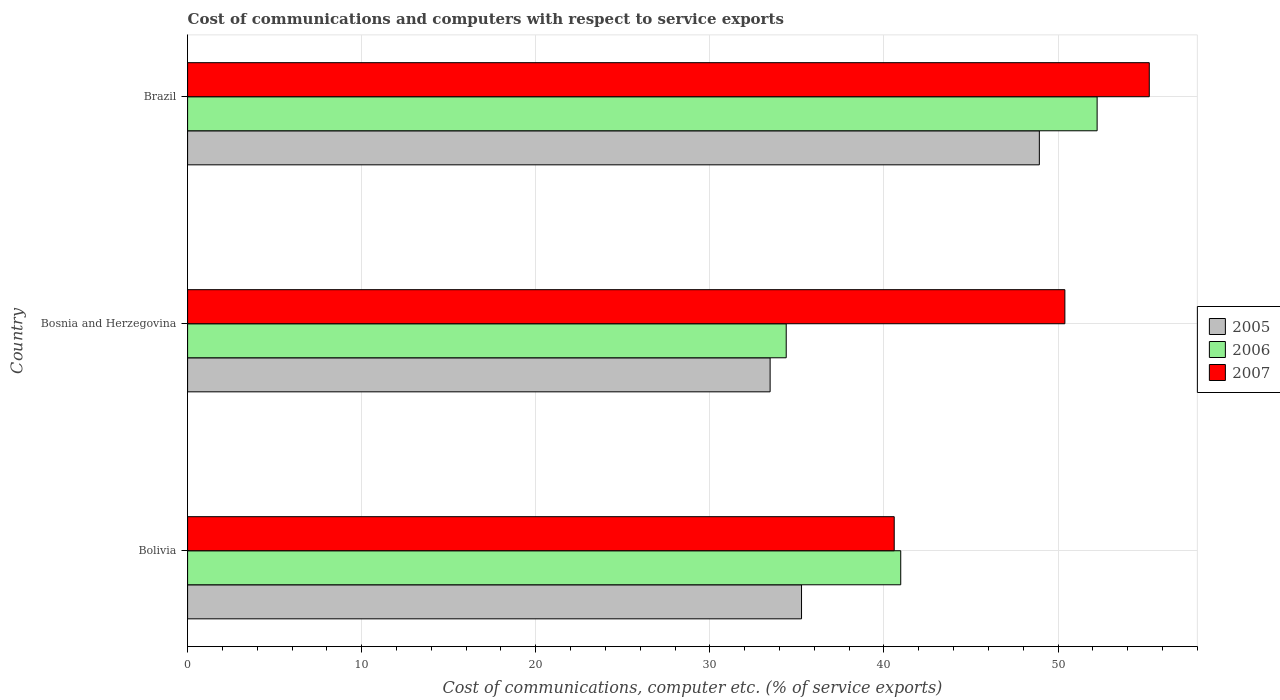How many different coloured bars are there?
Offer a very short reply. 3. How many groups of bars are there?
Your answer should be compact. 3. Are the number of bars per tick equal to the number of legend labels?
Offer a very short reply. Yes. How many bars are there on the 2nd tick from the bottom?
Give a very brief answer. 3. What is the label of the 2nd group of bars from the top?
Make the answer very short. Bosnia and Herzegovina. In how many cases, is the number of bars for a given country not equal to the number of legend labels?
Offer a very short reply. 0. What is the cost of communications and computers in 2006 in Bosnia and Herzegovina?
Your answer should be compact. 34.38. Across all countries, what is the maximum cost of communications and computers in 2005?
Your response must be concise. 48.92. Across all countries, what is the minimum cost of communications and computers in 2006?
Your answer should be very brief. 34.38. In which country was the cost of communications and computers in 2007 maximum?
Your answer should be very brief. Brazil. In which country was the cost of communications and computers in 2005 minimum?
Provide a short and direct response. Bosnia and Herzegovina. What is the total cost of communications and computers in 2007 in the graph?
Provide a succinct answer. 146.22. What is the difference between the cost of communications and computers in 2005 in Bosnia and Herzegovina and that in Brazil?
Make the answer very short. -15.46. What is the difference between the cost of communications and computers in 2005 in Bolivia and the cost of communications and computers in 2007 in Bosnia and Herzegovina?
Provide a short and direct response. -15.13. What is the average cost of communications and computers in 2006 per country?
Offer a very short reply. 42.53. What is the difference between the cost of communications and computers in 2006 and cost of communications and computers in 2005 in Brazil?
Offer a very short reply. 3.32. What is the ratio of the cost of communications and computers in 2005 in Bolivia to that in Bosnia and Herzegovina?
Provide a short and direct response. 1.05. Is the cost of communications and computers in 2007 in Bolivia less than that in Bosnia and Herzegovina?
Provide a succinct answer. Yes. Is the difference between the cost of communications and computers in 2006 in Bolivia and Bosnia and Herzegovina greater than the difference between the cost of communications and computers in 2005 in Bolivia and Bosnia and Herzegovina?
Offer a very short reply. Yes. What is the difference between the highest and the second highest cost of communications and computers in 2005?
Keep it short and to the point. 13.66. What is the difference between the highest and the lowest cost of communications and computers in 2006?
Your response must be concise. 17.86. What does the 2nd bar from the top in Bosnia and Herzegovina represents?
Keep it short and to the point. 2006. How many bars are there?
Offer a very short reply. 9. Are the values on the major ticks of X-axis written in scientific E-notation?
Your answer should be compact. No. Does the graph contain any zero values?
Give a very brief answer. No. Does the graph contain grids?
Give a very brief answer. Yes. Where does the legend appear in the graph?
Offer a terse response. Center right. How many legend labels are there?
Your response must be concise. 3. How are the legend labels stacked?
Make the answer very short. Vertical. What is the title of the graph?
Ensure brevity in your answer.  Cost of communications and computers with respect to service exports. Does "2013" appear as one of the legend labels in the graph?
Your response must be concise. No. What is the label or title of the X-axis?
Offer a terse response. Cost of communications, computer etc. (% of service exports). What is the label or title of the Y-axis?
Ensure brevity in your answer.  Country. What is the Cost of communications, computer etc. (% of service exports) in 2005 in Bolivia?
Your response must be concise. 35.26. What is the Cost of communications, computer etc. (% of service exports) in 2006 in Bolivia?
Offer a terse response. 40.96. What is the Cost of communications, computer etc. (% of service exports) of 2007 in Bolivia?
Make the answer very short. 40.59. What is the Cost of communications, computer etc. (% of service exports) in 2005 in Bosnia and Herzegovina?
Provide a succinct answer. 33.46. What is the Cost of communications, computer etc. (% of service exports) in 2006 in Bosnia and Herzegovina?
Give a very brief answer. 34.38. What is the Cost of communications, computer etc. (% of service exports) in 2007 in Bosnia and Herzegovina?
Offer a very short reply. 50.39. What is the Cost of communications, computer etc. (% of service exports) in 2005 in Brazil?
Make the answer very short. 48.92. What is the Cost of communications, computer etc. (% of service exports) of 2006 in Brazil?
Your answer should be compact. 52.24. What is the Cost of communications, computer etc. (% of service exports) in 2007 in Brazil?
Give a very brief answer. 55.24. Across all countries, what is the maximum Cost of communications, computer etc. (% of service exports) in 2005?
Provide a succinct answer. 48.92. Across all countries, what is the maximum Cost of communications, computer etc. (% of service exports) of 2006?
Your response must be concise. 52.24. Across all countries, what is the maximum Cost of communications, computer etc. (% of service exports) of 2007?
Your answer should be compact. 55.24. Across all countries, what is the minimum Cost of communications, computer etc. (% of service exports) in 2005?
Give a very brief answer. 33.46. Across all countries, what is the minimum Cost of communications, computer etc. (% of service exports) in 2006?
Ensure brevity in your answer.  34.38. Across all countries, what is the minimum Cost of communications, computer etc. (% of service exports) of 2007?
Your answer should be compact. 40.59. What is the total Cost of communications, computer etc. (% of service exports) in 2005 in the graph?
Keep it short and to the point. 117.65. What is the total Cost of communications, computer etc. (% of service exports) of 2006 in the graph?
Ensure brevity in your answer.  127.59. What is the total Cost of communications, computer etc. (% of service exports) of 2007 in the graph?
Provide a short and direct response. 146.22. What is the difference between the Cost of communications, computer etc. (% of service exports) in 2005 in Bolivia and that in Bosnia and Herzegovina?
Keep it short and to the point. 1.8. What is the difference between the Cost of communications, computer etc. (% of service exports) in 2006 in Bolivia and that in Bosnia and Herzegovina?
Your response must be concise. 6.58. What is the difference between the Cost of communications, computer etc. (% of service exports) in 2007 in Bolivia and that in Bosnia and Herzegovina?
Give a very brief answer. -9.8. What is the difference between the Cost of communications, computer etc. (% of service exports) in 2005 in Bolivia and that in Brazil?
Ensure brevity in your answer.  -13.66. What is the difference between the Cost of communications, computer etc. (% of service exports) of 2006 in Bolivia and that in Brazil?
Provide a short and direct response. -11.28. What is the difference between the Cost of communications, computer etc. (% of service exports) of 2007 in Bolivia and that in Brazil?
Provide a short and direct response. -14.65. What is the difference between the Cost of communications, computer etc. (% of service exports) of 2005 in Bosnia and Herzegovina and that in Brazil?
Offer a very short reply. -15.46. What is the difference between the Cost of communications, computer etc. (% of service exports) of 2006 in Bosnia and Herzegovina and that in Brazil?
Keep it short and to the point. -17.86. What is the difference between the Cost of communications, computer etc. (% of service exports) of 2007 in Bosnia and Herzegovina and that in Brazil?
Provide a succinct answer. -4.85. What is the difference between the Cost of communications, computer etc. (% of service exports) of 2005 in Bolivia and the Cost of communications, computer etc. (% of service exports) of 2007 in Bosnia and Herzegovina?
Offer a terse response. -15.13. What is the difference between the Cost of communications, computer etc. (% of service exports) of 2006 in Bolivia and the Cost of communications, computer etc. (% of service exports) of 2007 in Bosnia and Herzegovina?
Provide a short and direct response. -9.43. What is the difference between the Cost of communications, computer etc. (% of service exports) in 2005 in Bolivia and the Cost of communications, computer etc. (% of service exports) in 2006 in Brazil?
Provide a succinct answer. -16.98. What is the difference between the Cost of communications, computer etc. (% of service exports) of 2005 in Bolivia and the Cost of communications, computer etc. (% of service exports) of 2007 in Brazil?
Ensure brevity in your answer.  -19.97. What is the difference between the Cost of communications, computer etc. (% of service exports) in 2006 in Bolivia and the Cost of communications, computer etc. (% of service exports) in 2007 in Brazil?
Provide a succinct answer. -14.28. What is the difference between the Cost of communications, computer etc. (% of service exports) in 2005 in Bosnia and Herzegovina and the Cost of communications, computer etc. (% of service exports) in 2006 in Brazil?
Offer a very short reply. -18.78. What is the difference between the Cost of communications, computer etc. (% of service exports) in 2005 in Bosnia and Herzegovina and the Cost of communications, computer etc. (% of service exports) in 2007 in Brazil?
Offer a very short reply. -21.78. What is the difference between the Cost of communications, computer etc. (% of service exports) of 2006 in Bosnia and Herzegovina and the Cost of communications, computer etc. (% of service exports) of 2007 in Brazil?
Your response must be concise. -20.85. What is the average Cost of communications, computer etc. (% of service exports) of 2005 per country?
Keep it short and to the point. 39.22. What is the average Cost of communications, computer etc. (% of service exports) in 2006 per country?
Offer a very short reply. 42.53. What is the average Cost of communications, computer etc. (% of service exports) in 2007 per country?
Ensure brevity in your answer.  48.74. What is the difference between the Cost of communications, computer etc. (% of service exports) in 2005 and Cost of communications, computer etc. (% of service exports) in 2006 in Bolivia?
Ensure brevity in your answer.  -5.7. What is the difference between the Cost of communications, computer etc. (% of service exports) in 2005 and Cost of communications, computer etc. (% of service exports) in 2007 in Bolivia?
Your answer should be compact. -5.32. What is the difference between the Cost of communications, computer etc. (% of service exports) of 2006 and Cost of communications, computer etc. (% of service exports) of 2007 in Bolivia?
Your answer should be very brief. 0.37. What is the difference between the Cost of communications, computer etc. (% of service exports) of 2005 and Cost of communications, computer etc. (% of service exports) of 2006 in Bosnia and Herzegovina?
Your answer should be very brief. -0.92. What is the difference between the Cost of communications, computer etc. (% of service exports) in 2005 and Cost of communications, computer etc. (% of service exports) in 2007 in Bosnia and Herzegovina?
Give a very brief answer. -16.93. What is the difference between the Cost of communications, computer etc. (% of service exports) of 2006 and Cost of communications, computer etc. (% of service exports) of 2007 in Bosnia and Herzegovina?
Offer a very short reply. -16.01. What is the difference between the Cost of communications, computer etc. (% of service exports) in 2005 and Cost of communications, computer etc. (% of service exports) in 2006 in Brazil?
Offer a very short reply. -3.32. What is the difference between the Cost of communications, computer etc. (% of service exports) in 2005 and Cost of communications, computer etc. (% of service exports) in 2007 in Brazil?
Your response must be concise. -6.31. What is the difference between the Cost of communications, computer etc. (% of service exports) of 2006 and Cost of communications, computer etc. (% of service exports) of 2007 in Brazil?
Provide a succinct answer. -3. What is the ratio of the Cost of communications, computer etc. (% of service exports) in 2005 in Bolivia to that in Bosnia and Herzegovina?
Give a very brief answer. 1.05. What is the ratio of the Cost of communications, computer etc. (% of service exports) in 2006 in Bolivia to that in Bosnia and Herzegovina?
Keep it short and to the point. 1.19. What is the ratio of the Cost of communications, computer etc. (% of service exports) in 2007 in Bolivia to that in Bosnia and Herzegovina?
Provide a succinct answer. 0.81. What is the ratio of the Cost of communications, computer etc. (% of service exports) in 2005 in Bolivia to that in Brazil?
Offer a terse response. 0.72. What is the ratio of the Cost of communications, computer etc. (% of service exports) of 2006 in Bolivia to that in Brazil?
Your response must be concise. 0.78. What is the ratio of the Cost of communications, computer etc. (% of service exports) in 2007 in Bolivia to that in Brazil?
Ensure brevity in your answer.  0.73. What is the ratio of the Cost of communications, computer etc. (% of service exports) in 2005 in Bosnia and Herzegovina to that in Brazil?
Give a very brief answer. 0.68. What is the ratio of the Cost of communications, computer etc. (% of service exports) in 2006 in Bosnia and Herzegovina to that in Brazil?
Give a very brief answer. 0.66. What is the ratio of the Cost of communications, computer etc. (% of service exports) in 2007 in Bosnia and Herzegovina to that in Brazil?
Provide a short and direct response. 0.91. What is the difference between the highest and the second highest Cost of communications, computer etc. (% of service exports) in 2005?
Ensure brevity in your answer.  13.66. What is the difference between the highest and the second highest Cost of communications, computer etc. (% of service exports) in 2006?
Make the answer very short. 11.28. What is the difference between the highest and the second highest Cost of communications, computer etc. (% of service exports) in 2007?
Provide a succinct answer. 4.85. What is the difference between the highest and the lowest Cost of communications, computer etc. (% of service exports) in 2005?
Give a very brief answer. 15.46. What is the difference between the highest and the lowest Cost of communications, computer etc. (% of service exports) of 2006?
Provide a short and direct response. 17.86. What is the difference between the highest and the lowest Cost of communications, computer etc. (% of service exports) of 2007?
Your answer should be compact. 14.65. 